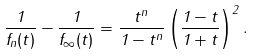Convert formula to latex. <formula><loc_0><loc_0><loc_500><loc_500>\frac { 1 } { f _ { n } ( t ) } - \frac { 1 } { f _ { \infty } ( t ) } = \frac { t ^ { n } } { 1 - t ^ { n } } \left ( \frac { 1 - t } { 1 + t } \right ) ^ { 2 } .</formula> 